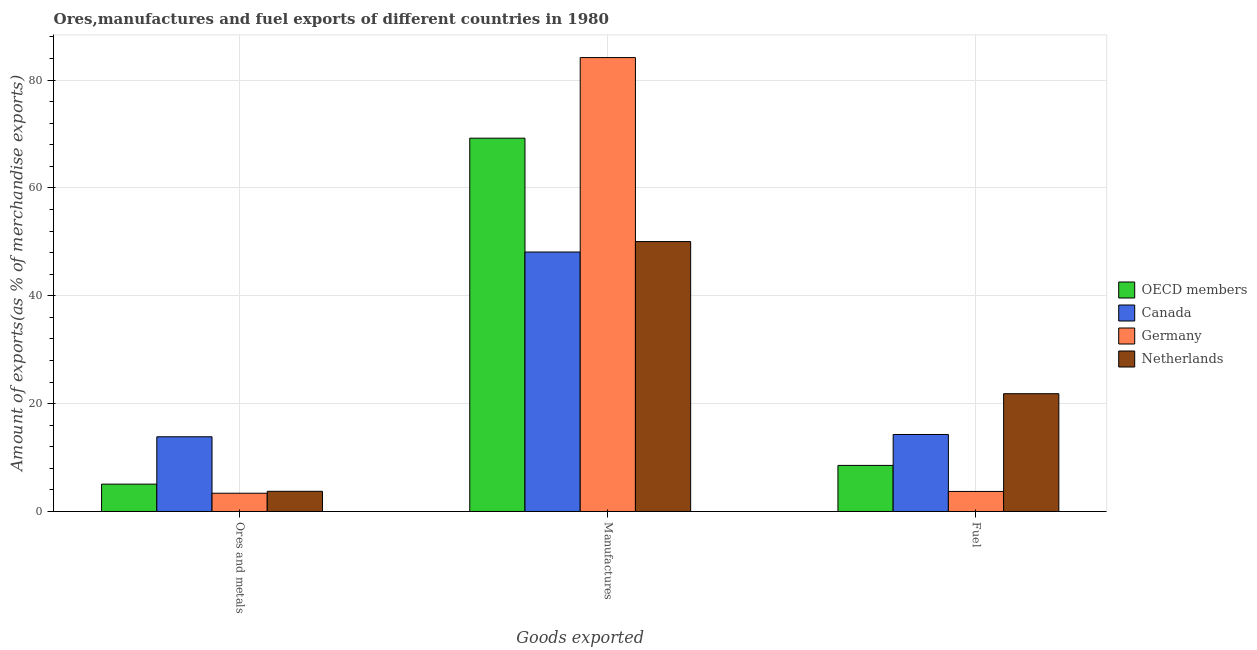How many different coloured bars are there?
Make the answer very short. 4. How many groups of bars are there?
Your answer should be compact. 3. Are the number of bars per tick equal to the number of legend labels?
Offer a terse response. Yes. How many bars are there on the 1st tick from the right?
Give a very brief answer. 4. What is the label of the 3rd group of bars from the left?
Give a very brief answer. Fuel. What is the percentage of ores and metals exports in Germany?
Your response must be concise. 3.39. Across all countries, what is the maximum percentage of manufactures exports?
Ensure brevity in your answer.  84.18. Across all countries, what is the minimum percentage of fuel exports?
Ensure brevity in your answer.  3.72. What is the total percentage of fuel exports in the graph?
Your answer should be very brief. 48.38. What is the difference between the percentage of ores and metals exports in Canada and that in OECD members?
Your answer should be very brief. 8.78. What is the difference between the percentage of manufactures exports in OECD members and the percentage of ores and metals exports in Netherlands?
Your answer should be very brief. 65.49. What is the average percentage of fuel exports per country?
Offer a terse response. 12.1. What is the difference between the percentage of ores and metals exports and percentage of fuel exports in OECD members?
Keep it short and to the point. -3.47. In how many countries, is the percentage of manufactures exports greater than 16 %?
Keep it short and to the point. 4. What is the ratio of the percentage of fuel exports in OECD members to that in Germany?
Provide a succinct answer. 2.3. Is the percentage of manufactures exports in OECD members less than that in Netherlands?
Give a very brief answer. No. Is the difference between the percentage of manufactures exports in OECD members and Netherlands greater than the difference between the percentage of fuel exports in OECD members and Netherlands?
Provide a short and direct response. Yes. What is the difference between the highest and the second highest percentage of fuel exports?
Offer a very short reply. 7.56. What is the difference between the highest and the lowest percentage of manufactures exports?
Your answer should be very brief. 36.06. In how many countries, is the percentage of manufactures exports greater than the average percentage of manufactures exports taken over all countries?
Provide a succinct answer. 2. Is the sum of the percentage of ores and metals exports in OECD members and Germany greater than the maximum percentage of manufactures exports across all countries?
Provide a short and direct response. No. What does the 2nd bar from the right in Manufactures represents?
Your response must be concise. Germany. Is it the case that in every country, the sum of the percentage of ores and metals exports and percentage of manufactures exports is greater than the percentage of fuel exports?
Make the answer very short. Yes. How many legend labels are there?
Offer a very short reply. 4. What is the title of the graph?
Your answer should be very brief. Ores,manufactures and fuel exports of different countries in 1980. What is the label or title of the X-axis?
Your answer should be very brief. Goods exported. What is the label or title of the Y-axis?
Provide a short and direct response. Amount of exports(as % of merchandise exports). What is the Amount of exports(as % of merchandise exports) in OECD members in Ores and metals?
Offer a very short reply. 5.07. What is the Amount of exports(as % of merchandise exports) in Canada in Ores and metals?
Your answer should be very brief. 13.86. What is the Amount of exports(as % of merchandise exports) of Germany in Ores and metals?
Your answer should be compact. 3.39. What is the Amount of exports(as % of merchandise exports) in Netherlands in Ores and metals?
Keep it short and to the point. 3.74. What is the Amount of exports(as % of merchandise exports) in OECD members in Manufactures?
Offer a very short reply. 69.23. What is the Amount of exports(as % of merchandise exports) of Canada in Manufactures?
Your answer should be very brief. 48.12. What is the Amount of exports(as % of merchandise exports) of Germany in Manufactures?
Your answer should be compact. 84.18. What is the Amount of exports(as % of merchandise exports) of Netherlands in Manufactures?
Offer a very short reply. 50.06. What is the Amount of exports(as % of merchandise exports) in OECD members in Fuel?
Keep it short and to the point. 8.55. What is the Amount of exports(as % of merchandise exports) of Canada in Fuel?
Ensure brevity in your answer.  14.28. What is the Amount of exports(as % of merchandise exports) in Germany in Fuel?
Offer a terse response. 3.72. What is the Amount of exports(as % of merchandise exports) of Netherlands in Fuel?
Provide a succinct answer. 21.84. Across all Goods exported, what is the maximum Amount of exports(as % of merchandise exports) in OECD members?
Give a very brief answer. 69.23. Across all Goods exported, what is the maximum Amount of exports(as % of merchandise exports) in Canada?
Give a very brief answer. 48.12. Across all Goods exported, what is the maximum Amount of exports(as % of merchandise exports) in Germany?
Your answer should be compact. 84.18. Across all Goods exported, what is the maximum Amount of exports(as % of merchandise exports) of Netherlands?
Provide a succinct answer. 50.06. Across all Goods exported, what is the minimum Amount of exports(as % of merchandise exports) in OECD members?
Give a very brief answer. 5.07. Across all Goods exported, what is the minimum Amount of exports(as % of merchandise exports) of Canada?
Offer a very short reply. 13.86. Across all Goods exported, what is the minimum Amount of exports(as % of merchandise exports) of Germany?
Keep it short and to the point. 3.39. Across all Goods exported, what is the minimum Amount of exports(as % of merchandise exports) of Netherlands?
Your answer should be very brief. 3.74. What is the total Amount of exports(as % of merchandise exports) of OECD members in the graph?
Keep it short and to the point. 82.85. What is the total Amount of exports(as % of merchandise exports) in Canada in the graph?
Keep it short and to the point. 76.26. What is the total Amount of exports(as % of merchandise exports) of Germany in the graph?
Your answer should be very brief. 91.29. What is the total Amount of exports(as % of merchandise exports) of Netherlands in the graph?
Provide a succinct answer. 75.64. What is the difference between the Amount of exports(as % of merchandise exports) in OECD members in Ores and metals and that in Manufactures?
Your answer should be very brief. -64.16. What is the difference between the Amount of exports(as % of merchandise exports) in Canada in Ores and metals and that in Manufactures?
Your response must be concise. -34.26. What is the difference between the Amount of exports(as % of merchandise exports) in Germany in Ores and metals and that in Manufactures?
Your response must be concise. -80.8. What is the difference between the Amount of exports(as % of merchandise exports) in Netherlands in Ores and metals and that in Manufactures?
Offer a very short reply. -46.32. What is the difference between the Amount of exports(as % of merchandise exports) of OECD members in Ores and metals and that in Fuel?
Your answer should be compact. -3.47. What is the difference between the Amount of exports(as % of merchandise exports) in Canada in Ores and metals and that in Fuel?
Keep it short and to the point. -0.42. What is the difference between the Amount of exports(as % of merchandise exports) of Germany in Ores and metals and that in Fuel?
Provide a succinct answer. -0.33. What is the difference between the Amount of exports(as % of merchandise exports) in Netherlands in Ores and metals and that in Fuel?
Make the answer very short. -18.1. What is the difference between the Amount of exports(as % of merchandise exports) of OECD members in Manufactures and that in Fuel?
Give a very brief answer. 60.69. What is the difference between the Amount of exports(as % of merchandise exports) in Canada in Manufactures and that in Fuel?
Offer a terse response. 33.84. What is the difference between the Amount of exports(as % of merchandise exports) in Germany in Manufactures and that in Fuel?
Provide a short and direct response. 80.47. What is the difference between the Amount of exports(as % of merchandise exports) of Netherlands in Manufactures and that in Fuel?
Your answer should be compact. 28.22. What is the difference between the Amount of exports(as % of merchandise exports) in OECD members in Ores and metals and the Amount of exports(as % of merchandise exports) in Canada in Manufactures?
Keep it short and to the point. -43.05. What is the difference between the Amount of exports(as % of merchandise exports) of OECD members in Ores and metals and the Amount of exports(as % of merchandise exports) of Germany in Manufactures?
Make the answer very short. -79.11. What is the difference between the Amount of exports(as % of merchandise exports) in OECD members in Ores and metals and the Amount of exports(as % of merchandise exports) in Netherlands in Manufactures?
Provide a succinct answer. -44.99. What is the difference between the Amount of exports(as % of merchandise exports) of Canada in Ores and metals and the Amount of exports(as % of merchandise exports) of Germany in Manufactures?
Provide a succinct answer. -70.33. What is the difference between the Amount of exports(as % of merchandise exports) in Canada in Ores and metals and the Amount of exports(as % of merchandise exports) in Netherlands in Manufactures?
Give a very brief answer. -36.2. What is the difference between the Amount of exports(as % of merchandise exports) in Germany in Ores and metals and the Amount of exports(as % of merchandise exports) in Netherlands in Manufactures?
Your answer should be compact. -46.67. What is the difference between the Amount of exports(as % of merchandise exports) in OECD members in Ores and metals and the Amount of exports(as % of merchandise exports) in Canada in Fuel?
Make the answer very short. -9.21. What is the difference between the Amount of exports(as % of merchandise exports) of OECD members in Ores and metals and the Amount of exports(as % of merchandise exports) of Germany in Fuel?
Give a very brief answer. 1.36. What is the difference between the Amount of exports(as % of merchandise exports) in OECD members in Ores and metals and the Amount of exports(as % of merchandise exports) in Netherlands in Fuel?
Your answer should be compact. -16.77. What is the difference between the Amount of exports(as % of merchandise exports) of Canada in Ores and metals and the Amount of exports(as % of merchandise exports) of Germany in Fuel?
Offer a terse response. 10.14. What is the difference between the Amount of exports(as % of merchandise exports) in Canada in Ores and metals and the Amount of exports(as % of merchandise exports) in Netherlands in Fuel?
Provide a succinct answer. -7.99. What is the difference between the Amount of exports(as % of merchandise exports) in Germany in Ores and metals and the Amount of exports(as % of merchandise exports) in Netherlands in Fuel?
Your answer should be very brief. -18.45. What is the difference between the Amount of exports(as % of merchandise exports) of OECD members in Manufactures and the Amount of exports(as % of merchandise exports) of Canada in Fuel?
Offer a very short reply. 54.95. What is the difference between the Amount of exports(as % of merchandise exports) of OECD members in Manufactures and the Amount of exports(as % of merchandise exports) of Germany in Fuel?
Offer a very short reply. 65.52. What is the difference between the Amount of exports(as % of merchandise exports) in OECD members in Manufactures and the Amount of exports(as % of merchandise exports) in Netherlands in Fuel?
Give a very brief answer. 47.39. What is the difference between the Amount of exports(as % of merchandise exports) in Canada in Manufactures and the Amount of exports(as % of merchandise exports) in Germany in Fuel?
Your answer should be very brief. 44.41. What is the difference between the Amount of exports(as % of merchandise exports) in Canada in Manufactures and the Amount of exports(as % of merchandise exports) in Netherlands in Fuel?
Give a very brief answer. 26.28. What is the difference between the Amount of exports(as % of merchandise exports) in Germany in Manufactures and the Amount of exports(as % of merchandise exports) in Netherlands in Fuel?
Your answer should be compact. 62.34. What is the average Amount of exports(as % of merchandise exports) in OECD members per Goods exported?
Offer a very short reply. 27.62. What is the average Amount of exports(as % of merchandise exports) of Canada per Goods exported?
Your response must be concise. 25.42. What is the average Amount of exports(as % of merchandise exports) of Germany per Goods exported?
Provide a succinct answer. 30.43. What is the average Amount of exports(as % of merchandise exports) in Netherlands per Goods exported?
Provide a succinct answer. 25.21. What is the difference between the Amount of exports(as % of merchandise exports) of OECD members and Amount of exports(as % of merchandise exports) of Canada in Ores and metals?
Offer a very short reply. -8.78. What is the difference between the Amount of exports(as % of merchandise exports) in OECD members and Amount of exports(as % of merchandise exports) in Germany in Ores and metals?
Provide a succinct answer. 1.69. What is the difference between the Amount of exports(as % of merchandise exports) in OECD members and Amount of exports(as % of merchandise exports) in Netherlands in Ores and metals?
Your answer should be compact. 1.33. What is the difference between the Amount of exports(as % of merchandise exports) in Canada and Amount of exports(as % of merchandise exports) in Germany in Ores and metals?
Your answer should be very brief. 10.47. What is the difference between the Amount of exports(as % of merchandise exports) of Canada and Amount of exports(as % of merchandise exports) of Netherlands in Ores and metals?
Your answer should be compact. 10.12. What is the difference between the Amount of exports(as % of merchandise exports) in Germany and Amount of exports(as % of merchandise exports) in Netherlands in Ores and metals?
Offer a terse response. -0.35. What is the difference between the Amount of exports(as % of merchandise exports) in OECD members and Amount of exports(as % of merchandise exports) in Canada in Manufactures?
Offer a terse response. 21.11. What is the difference between the Amount of exports(as % of merchandise exports) in OECD members and Amount of exports(as % of merchandise exports) in Germany in Manufactures?
Give a very brief answer. -14.95. What is the difference between the Amount of exports(as % of merchandise exports) in OECD members and Amount of exports(as % of merchandise exports) in Netherlands in Manufactures?
Ensure brevity in your answer.  19.17. What is the difference between the Amount of exports(as % of merchandise exports) in Canada and Amount of exports(as % of merchandise exports) in Germany in Manufactures?
Provide a succinct answer. -36.06. What is the difference between the Amount of exports(as % of merchandise exports) in Canada and Amount of exports(as % of merchandise exports) in Netherlands in Manufactures?
Make the answer very short. -1.94. What is the difference between the Amount of exports(as % of merchandise exports) of Germany and Amount of exports(as % of merchandise exports) of Netherlands in Manufactures?
Offer a terse response. 34.12. What is the difference between the Amount of exports(as % of merchandise exports) of OECD members and Amount of exports(as % of merchandise exports) of Canada in Fuel?
Your answer should be very brief. -5.73. What is the difference between the Amount of exports(as % of merchandise exports) of OECD members and Amount of exports(as % of merchandise exports) of Germany in Fuel?
Give a very brief answer. 4.83. What is the difference between the Amount of exports(as % of merchandise exports) in OECD members and Amount of exports(as % of merchandise exports) in Netherlands in Fuel?
Your response must be concise. -13.29. What is the difference between the Amount of exports(as % of merchandise exports) in Canada and Amount of exports(as % of merchandise exports) in Germany in Fuel?
Your answer should be compact. 10.56. What is the difference between the Amount of exports(as % of merchandise exports) of Canada and Amount of exports(as % of merchandise exports) of Netherlands in Fuel?
Provide a succinct answer. -7.56. What is the difference between the Amount of exports(as % of merchandise exports) in Germany and Amount of exports(as % of merchandise exports) in Netherlands in Fuel?
Offer a terse response. -18.13. What is the ratio of the Amount of exports(as % of merchandise exports) in OECD members in Ores and metals to that in Manufactures?
Provide a succinct answer. 0.07. What is the ratio of the Amount of exports(as % of merchandise exports) of Canada in Ores and metals to that in Manufactures?
Your answer should be compact. 0.29. What is the ratio of the Amount of exports(as % of merchandise exports) in Germany in Ores and metals to that in Manufactures?
Make the answer very short. 0.04. What is the ratio of the Amount of exports(as % of merchandise exports) of Netherlands in Ores and metals to that in Manufactures?
Offer a terse response. 0.07. What is the ratio of the Amount of exports(as % of merchandise exports) in OECD members in Ores and metals to that in Fuel?
Your answer should be very brief. 0.59. What is the ratio of the Amount of exports(as % of merchandise exports) of Canada in Ores and metals to that in Fuel?
Your answer should be compact. 0.97. What is the ratio of the Amount of exports(as % of merchandise exports) of Germany in Ores and metals to that in Fuel?
Provide a succinct answer. 0.91. What is the ratio of the Amount of exports(as % of merchandise exports) of Netherlands in Ores and metals to that in Fuel?
Provide a short and direct response. 0.17. What is the ratio of the Amount of exports(as % of merchandise exports) of Canada in Manufactures to that in Fuel?
Give a very brief answer. 3.37. What is the ratio of the Amount of exports(as % of merchandise exports) in Germany in Manufactures to that in Fuel?
Give a very brief answer. 22.65. What is the ratio of the Amount of exports(as % of merchandise exports) in Netherlands in Manufactures to that in Fuel?
Your response must be concise. 2.29. What is the difference between the highest and the second highest Amount of exports(as % of merchandise exports) in OECD members?
Make the answer very short. 60.69. What is the difference between the highest and the second highest Amount of exports(as % of merchandise exports) of Canada?
Offer a very short reply. 33.84. What is the difference between the highest and the second highest Amount of exports(as % of merchandise exports) of Germany?
Your answer should be compact. 80.47. What is the difference between the highest and the second highest Amount of exports(as % of merchandise exports) of Netherlands?
Keep it short and to the point. 28.22. What is the difference between the highest and the lowest Amount of exports(as % of merchandise exports) of OECD members?
Ensure brevity in your answer.  64.16. What is the difference between the highest and the lowest Amount of exports(as % of merchandise exports) of Canada?
Offer a very short reply. 34.26. What is the difference between the highest and the lowest Amount of exports(as % of merchandise exports) of Germany?
Make the answer very short. 80.8. What is the difference between the highest and the lowest Amount of exports(as % of merchandise exports) in Netherlands?
Your response must be concise. 46.32. 